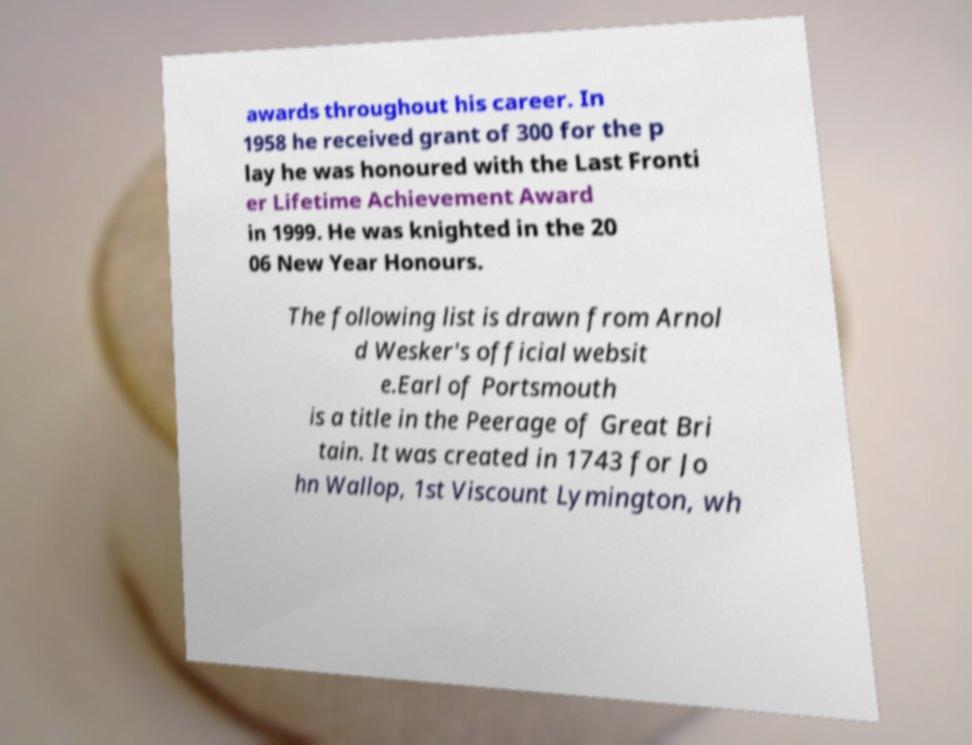What messages or text are displayed in this image? I need them in a readable, typed format. awards throughout his career. In 1958 he received grant of 300 for the p lay he was honoured with the Last Fronti er Lifetime Achievement Award in 1999. He was knighted in the 20 06 New Year Honours. The following list is drawn from Arnol d Wesker's official websit e.Earl of Portsmouth is a title in the Peerage of Great Bri tain. It was created in 1743 for Jo hn Wallop, 1st Viscount Lymington, wh 